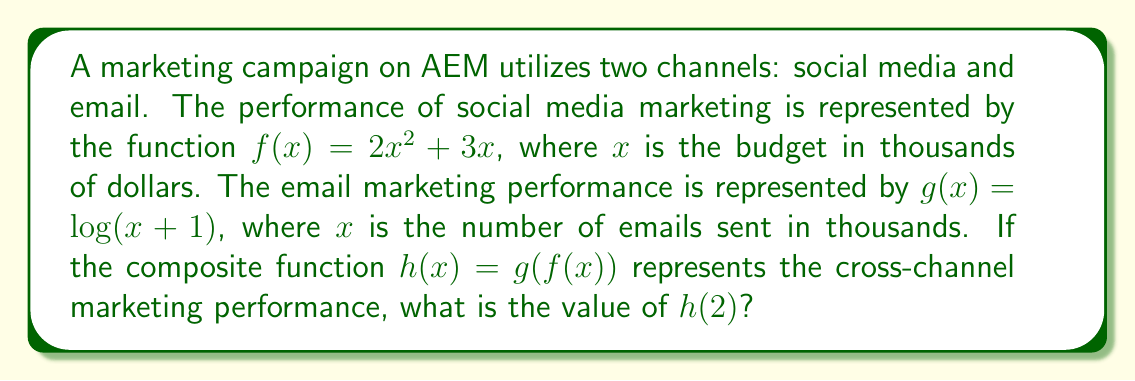What is the answer to this math problem? To solve this problem, we need to follow these steps:

1) First, we need to calculate $f(2)$:
   $f(2) = 2(2)^2 + 3(2) = 2(4) + 6 = 8 + 6 = 14$

2) Now that we have $f(2) = 14$, we need to use this as the input for $g(x)$:
   $h(2) = g(f(2)) = g(14)$

3) Substituting 14 into the function $g(x)$:
   $g(14) = \log(14+1) = \log(15)$

4) $\log(15)$ is the natural logarithm of 15, which is approximately 2.7081.

Therefore, $h(2) = \log(15) \approx 2.7081$
Answer: $\log(15)$ 